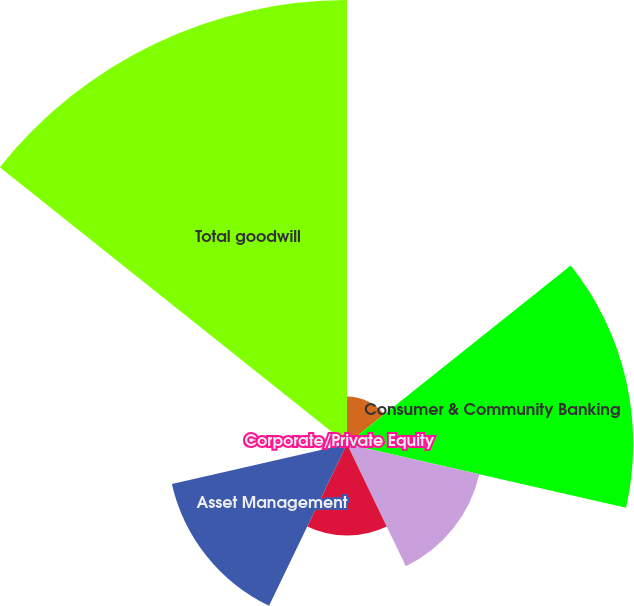<chart> <loc_0><loc_0><loc_500><loc_500><pie_chart><fcel>December 31 (in millions)<fcel>Consumer & Community Banking<fcel>Corporate & Investment Bank<fcel>Commercial Banking<fcel>Asset Management<fcel>Corporate/Private Equity<fcel>Total goodwill<nl><fcel>4.0%<fcel>24.09%<fcel>11.42%<fcel>7.71%<fcel>15.12%<fcel>0.29%<fcel>37.37%<nl></chart> 